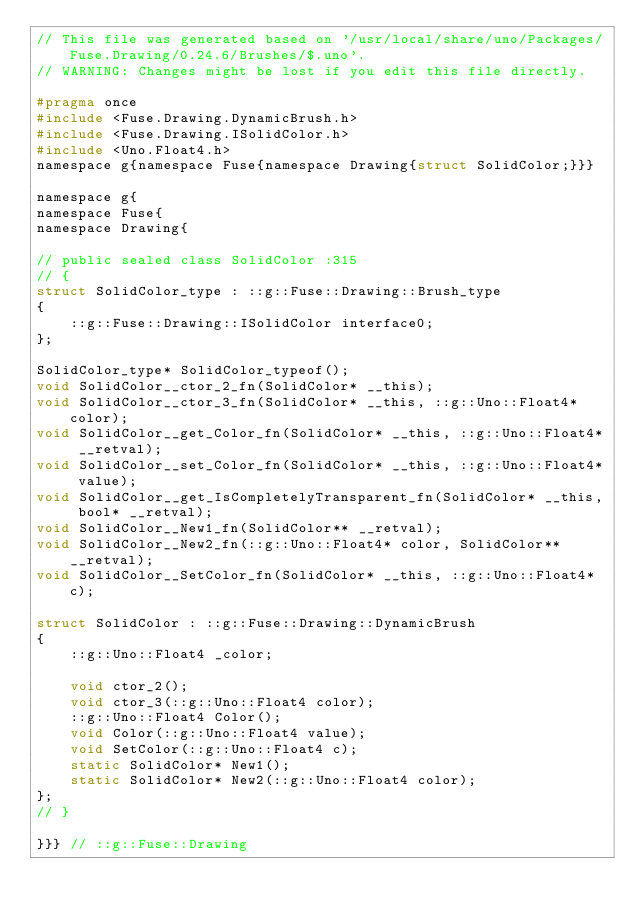Convert code to text. <code><loc_0><loc_0><loc_500><loc_500><_C_>// This file was generated based on '/usr/local/share/uno/Packages/Fuse.Drawing/0.24.6/Brushes/$.uno'.
// WARNING: Changes might be lost if you edit this file directly.

#pragma once
#include <Fuse.Drawing.DynamicBrush.h>
#include <Fuse.Drawing.ISolidColor.h>
#include <Uno.Float4.h>
namespace g{namespace Fuse{namespace Drawing{struct SolidColor;}}}

namespace g{
namespace Fuse{
namespace Drawing{

// public sealed class SolidColor :315
// {
struct SolidColor_type : ::g::Fuse::Drawing::Brush_type
{
    ::g::Fuse::Drawing::ISolidColor interface0;
};

SolidColor_type* SolidColor_typeof();
void SolidColor__ctor_2_fn(SolidColor* __this);
void SolidColor__ctor_3_fn(SolidColor* __this, ::g::Uno::Float4* color);
void SolidColor__get_Color_fn(SolidColor* __this, ::g::Uno::Float4* __retval);
void SolidColor__set_Color_fn(SolidColor* __this, ::g::Uno::Float4* value);
void SolidColor__get_IsCompletelyTransparent_fn(SolidColor* __this, bool* __retval);
void SolidColor__New1_fn(SolidColor** __retval);
void SolidColor__New2_fn(::g::Uno::Float4* color, SolidColor** __retval);
void SolidColor__SetColor_fn(SolidColor* __this, ::g::Uno::Float4* c);

struct SolidColor : ::g::Fuse::Drawing::DynamicBrush
{
    ::g::Uno::Float4 _color;

    void ctor_2();
    void ctor_3(::g::Uno::Float4 color);
    ::g::Uno::Float4 Color();
    void Color(::g::Uno::Float4 value);
    void SetColor(::g::Uno::Float4 c);
    static SolidColor* New1();
    static SolidColor* New2(::g::Uno::Float4 color);
};
// }

}}} // ::g::Fuse::Drawing
</code> 